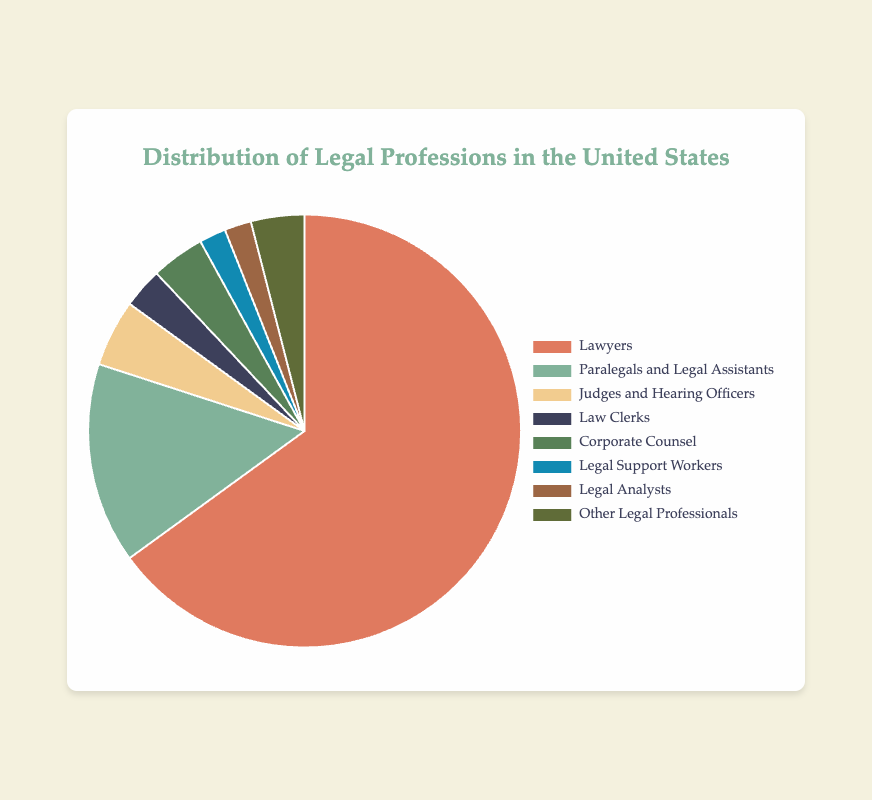What percentage of legal professions in the United States are accounted for by Lawyers and Corporate Counsel combined? Add the percentages of Lawyers (65%) and Corporate Counsel (4%). 65% + 4% = 69%.
Answer: 69% Is the percentage of Paralegals and Legal Assistants greater or less than the percentage of Legal Support Workers and Legal Analysts combined? Combine the percentages of Legal Support Workers (2%) and Legal Analysts (2%). Then compare with Paralegals and Legal Assistants (15%). 2% + 2% = 4%, which is less than 15%.
Answer: Less Which category has the second smallest percentage after Legal Support Workers and Legal Analysts? The smallest percentages are Legal Support Workers (2%) and Legal Analysts (2%). The next smallest is Law Clerks with 3%.
Answer: Law Clerks What is the difference in percentage between Lawyers and all other professions combined? Sum the percentages of all non-Lawyers categories: 15% + 5% + 3% + 4% + 2% + 2% + 4% = 35%. Then find the difference from Lawyers (65%): 65% - 35% = 30%.
Answer: 30% What is the average percentage of Judges and Hearing Officers, Corporate Counsel, and Other Legal Professionals? Sum the percentages: 5% + 4% + 4% = 13%. Divide by the number of categories (3). 13% / 3 ≈ 4.33%.
Answer: 4.33% Which category is represented in green on the pie chart, and what is its percentage? The green category corresponds to the second color in the dataset list, which is assigned to Paralegals and Legal Assistants. It is 15%.
Answer: Paralegals and Legal Assistants, 15% How much larger is the percentage of Lawyers compared to Law Clerks? Subtract the percentage of Law Clerks (3%) from Lawyers (65%). 65% - 3% = 62%.
Answer: 62% What percentage of the chart is represented by categories occupying less than 5% each? Combine percentages of categories less than 5%: Judges and Hearing Officers (5%), Law Clerks (3%), Legal Support Workers (2%), Legal Analysts (2%), Other Legal Professionals (4%). 5% + 3% + 2% + 2% + 4% = 16%.
Answer: 16% How many categories have a percentage greater than or equal to 4%? Identify categories: Lawyers (65%), Paralegals and Legal Assistants (15%), Judges and Hearing Officers (5%), Corporate Counsel (4%), Other Legal Professionals (4%). There are 5 categories.
Answer: 5 